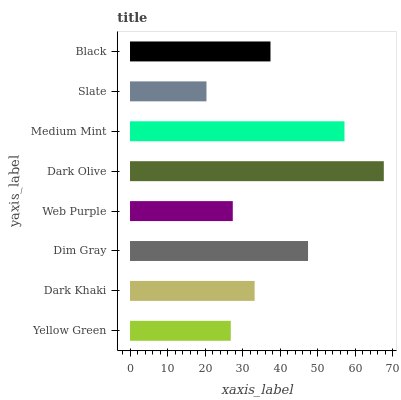Is Slate the minimum?
Answer yes or no. Yes. Is Dark Olive the maximum?
Answer yes or no. Yes. Is Dark Khaki the minimum?
Answer yes or no. No. Is Dark Khaki the maximum?
Answer yes or no. No. Is Dark Khaki greater than Yellow Green?
Answer yes or no. Yes. Is Yellow Green less than Dark Khaki?
Answer yes or no. Yes. Is Yellow Green greater than Dark Khaki?
Answer yes or no. No. Is Dark Khaki less than Yellow Green?
Answer yes or no. No. Is Black the high median?
Answer yes or no. Yes. Is Dark Khaki the low median?
Answer yes or no. Yes. Is Yellow Green the high median?
Answer yes or no. No. Is Slate the low median?
Answer yes or no. No. 